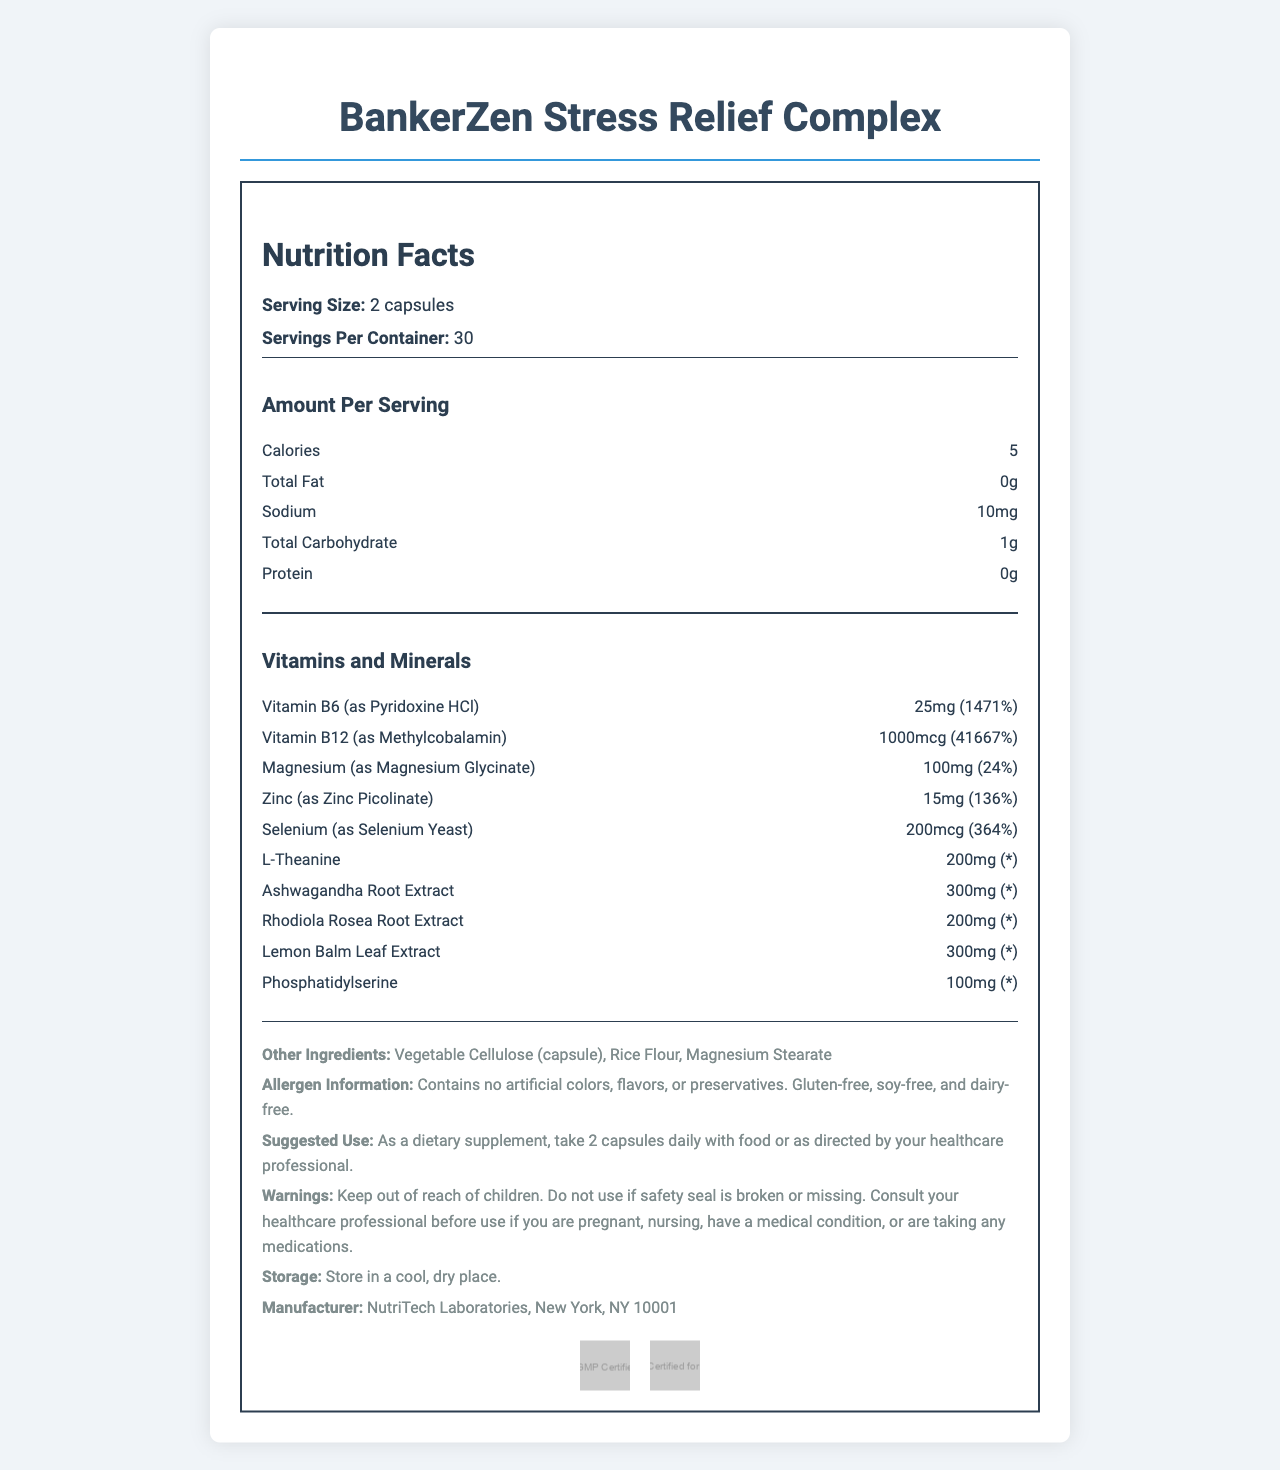what is the serving size of BankerZen Stress Relief Complex? The document clearly states that the serving size is 2 capsules.
Answer: 2 capsules how many servings are in each container? According to the document, each container has 30 servings.
Answer: 30 servings how many calories are in each serving? The document lists the calorie content as 5 calories per serving.
Answer: 5 calories what is the percentage of daily value for Vitamin B6 in a single serving? The amount of Vitamin B6 (25mg) corresponds to 1471% of the daily value, as stated in the document.
Answer: 1471% which vitamin has the highest daily value percentage in a serving? The document specifies that the daily value percentage for Vitamin B12 is 41667%.
Answer: Vitamin B12 which mineral has a daily value percentage of 24% in a single serving? A. Zinc B. Magnesium C. Selenium The document indicates that Magnesium has a daily value percentage of 24%.
Answer: B. Magnesium which of the following ingredients is not present in the BankerZen Stress Relief Complex? A. Rice Flour B. Magnesium Stearate C. Gelatin The document lists Rice Flour and Magnesium Stearate as ingredients but does not mention Gelatin.
Answer: C. Gelatin is the BankerZen Stress Relief Complex safe for children? The document warns to keep the product out of reach of children.
Answer: No Can you summarize the main idea of the nutrition facts document for BankerZen Stress Relief Complex? The document aims to inform users about the nutritional and ingredient specifics of the BankerZen Stress Relief Complex, ensuring they are aware of its composition and usage guidelines.
Answer: The document provides detailed information about the BankerZen Stress Relief Complex, including its serving size, nutritional content, vitamin and mineral percentages, ingredient list, allergen information, suggested use, warnings, storage instructions, and manufacturer details. can we determine the exact time of day when the supplement should be taken from the document? The document suggests taking the supplement with food but does not specify an exact time of day.
Answer: Not enough information what certifications does the BankerZen Stress Relief Complex have? The document lists cGMP Certified and NSF Certified for Sport as the certifications.
Answer: cGMP Certified, NSF Certified for Sport what are the primary vitamins included in the BankerZen Stress Relief Complex? The document lists Vitamin B6 and Vitamin B12 as the primary vitamins included.
Answer: Vitamin B6, Vitamin B12 are there any artificial colors, flavors, or preservatives in BankerZen Stress Relief Complex? The document states that the product contains no artificial colors, flavors, or preservatives.
Answer: No what is the amount of Ashwagandha Root Extract per serving? The document specifies that each serving contains 300mg of Ashwagandha Root Extract.
Answer: 300mg does the product contain gluten, soy, or dairy? The allergen information in the document confirms that the product is gluten-free, soy-free, and dairy-free.
Answer: No who manufactures the BankerZen Stress Relief Complex? The manufacturer listed in the document is NutriTech Laboratories, New York, NY 10001.
Answer: NutriTech Laboratories, New York, NY 10001 